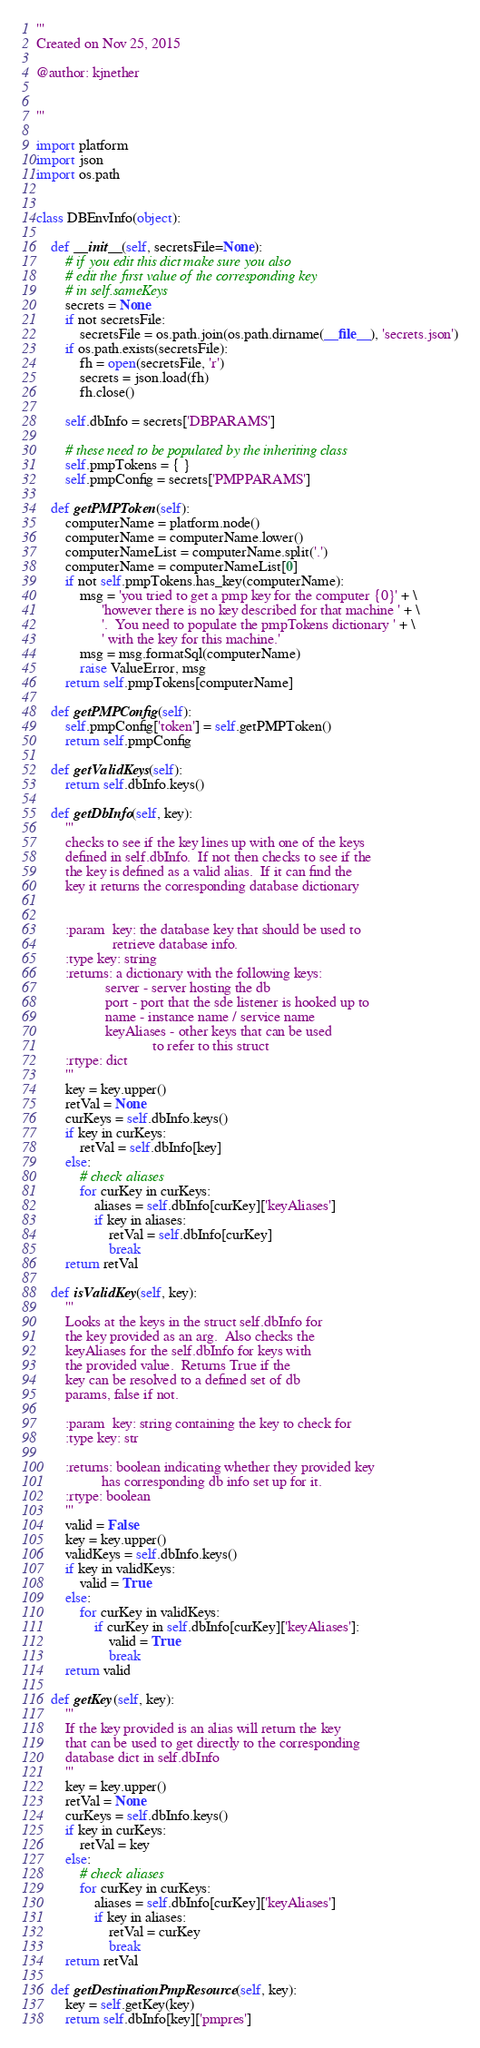<code> <loc_0><loc_0><loc_500><loc_500><_Python_>'''
Created on Nov 25, 2015

@author: kjnether


'''

import platform
import json
import os.path


class DBEnvInfo(object):

    def __init__(self, secretsFile=None):
        # if you edit this dict make sure you also
        # edit the first value of the corresponding key
        # in self.sameKeys
        secrets = None
        if not secretsFile:
            secretsFile = os.path.join(os.path.dirname(__file__), 'secrets.json')
        if os.path.exists(secretsFile):
            fh = open(secretsFile, 'r')
            secrets = json.load(fh)
            fh.close()

        self.dbInfo = secrets['DBPARAMS']

        # these need to be populated by the inheriting class
        self.pmpTokens = { }
        self.pmpConfig = secrets['PMPPARAMS']

    def getPMPToken(self):
        computerName = platform.node()
        computerName = computerName.lower()
        computerNameList = computerName.split('.')
        computerName = computerNameList[0]
        if not self.pmpTokens.has_key(computerName):
            msg = 'you tried to get a pmp key for the computer {0}' + \
                  'however there is no key described for that machine ' + \
                  '.  You need to populate the pmpTokens dictionary ' + \
                  ' with the key for this machine.'
            msg = msg.formatSql(computerName)
            raise ValueError, msg
        return self.pmpTokens[computerName]

    def getPMPConfig(self):
        self.pmpConfig['token'] = self.getPMPToken()
        return self.pmpConfig

    def getValidKeys(self):
        return self.dbInfo.keys()

    def getDbInfo(self, key):
        '''
        checks to see if the key lines up with one of the keys
        defined in self.dbInfo.  If not then checks to see if the
        the key is defined as a valid alias.  If it can find the
        key it returns the corresponding database dictionary


        :param  key: the database key that should be used to
                     retrieve database info.
        :type key: string
        :returns: a dictionary with the following keys:
                   server - server hosting the db
                   port - port that the sde listener is hooked up to
                   name - instance name / service name
                   keyAliases - other keys that can be used
                                to refer to this struct
        :rtype: dict
        '''
        key = key.upper()
        retVal = None
        curKeys = self.dbInfo.keys()
        if key in curKeys:
            retVal = self.dbInfo[key]
        else:
            # check aliases
            for curKey in curKeys:
                aliases = self.dbInfo[curKey]['keyAliases']
                if key in aliases:
                    retVal = self.dbInfo[curKey]
                    break
        return retVal

    def isValidKey(self, key):
        '''
        Looks at the keys in the struct self.dbInfo for
        the key provided as an arg.  Also checks the
        keyAliases for the self.dbInfo for keys with
        the provided value.  Returns True if the
        key can be resolved to a defined set of db
        params, false if not.

        :param  key: string containing the key to check for
        :type key: str

        :returns: boolean indicating whether they provided key
                  has corresponding db info set up for it.
        :rtype: boolean
        '''
        valid = False
        key = key.upper()
        validKeys = self.dbInfo.keys()
        if key in validKeys:
            valid = True
        else:
            for curKey in validKeys:
                if curKey in self.dbInfo[curKey]['keyAliases']:
                    valid = True
                    break
        return valid

    def getKey(self, key):
        '''
        If the key provided is an alias will return the key
        that can be used to get directly to the corresponding
        database dict in self.dbInfo
        '''
        key = key.upper()
        retVal = None
        curKeys = self.dbInfo.keys()
        if key in curKeys:
            retVal = key
        else:
            # check aliases
            for curKey in curKeys:
                aliases = self.dbInfo[curKey]['keyAliases']
                if key in aliases:
                    retVal = curKey
                    break
        return retVal

    def getDestinationPmpResource(self, key):
        key = self.getKey(key)
        return self.dbInfo[key]['pmpres']

</code> 